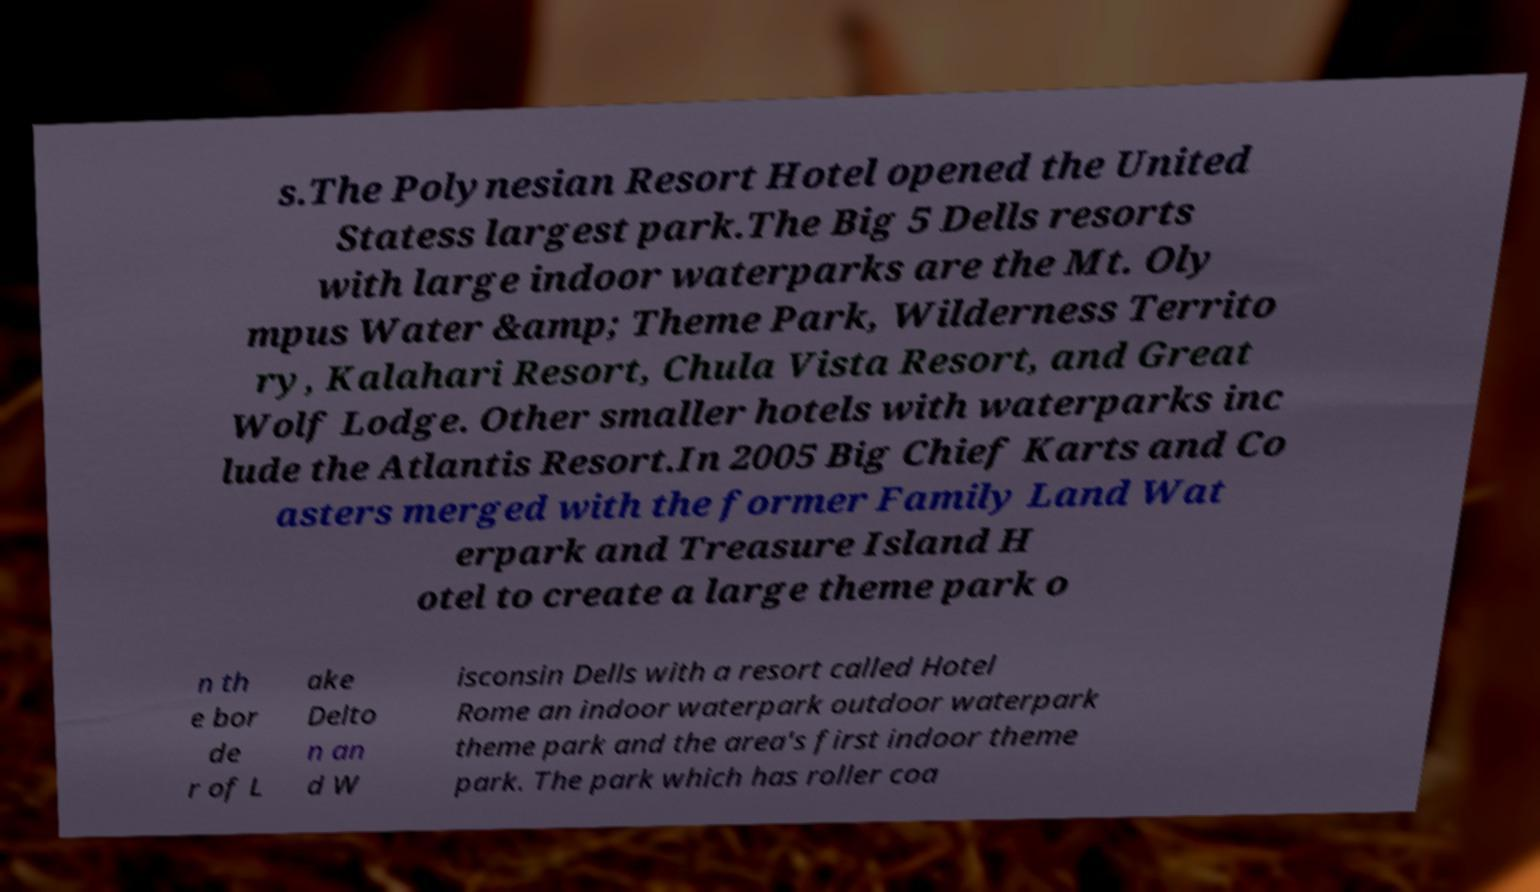What messages or text are displayed in this image? I need them in a readable, typed format. s.The Polynesian Resort Hotel opened the United Statess largest park.The Big 5 Dells resorts with large indoor waterparks are the Mt. Oly mpus Water &amp; Theme Park, Wilderness Territo ry, Kalahari Resort, Chula Vista Resort, and Great Wolf Lodge. Other smaller hotels with waterparks inc lude the Atlantis Resort.In 2005 Big Chief Karts and Co asters merged with the former Family Land Wat erpark and Treasure Island H otel to create a large theme park o n th e bor de r of L ake Delto n an d W isconsin Dells with a resort called Hotel Rome an indoor waterpark outdoor waterpark theme park and the area's first indoor theme park. The park which has roller coa 